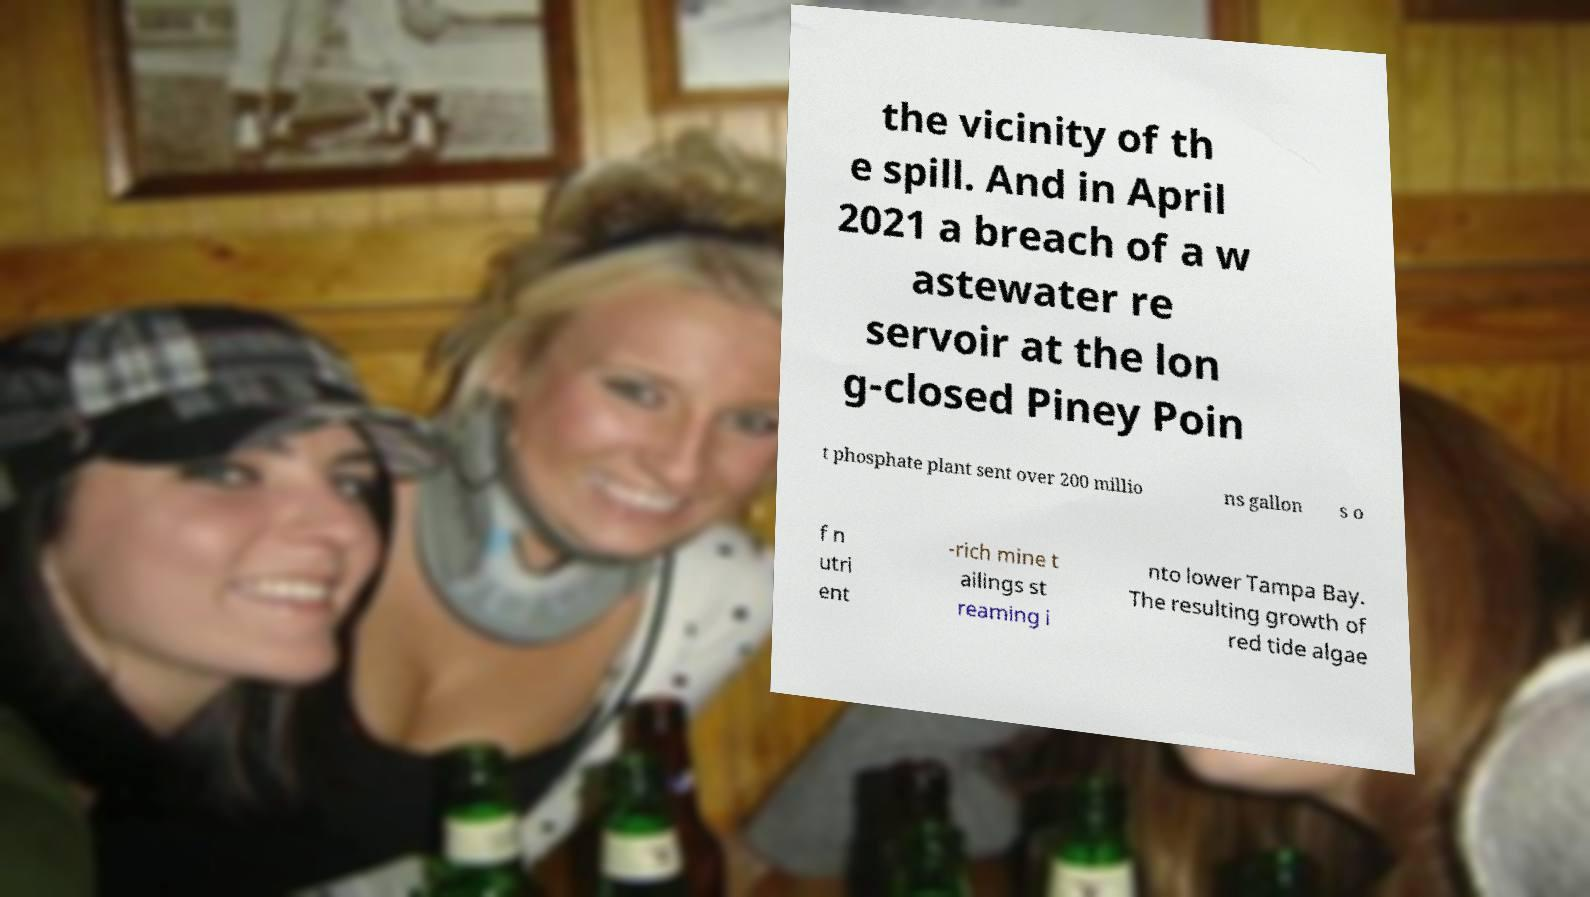Please identify and transcribe the text found in this image. the vicinity of th e spill. And in April 2021 a breach of a w astewater re servoir at the lon g-closed Piney Poin t phosphate plant sent over 200 millio ns gallon s o f n utri ent -rich mine t ailings st reaming i nto lower Tampa Bay. The resulting growth of red tide algae 